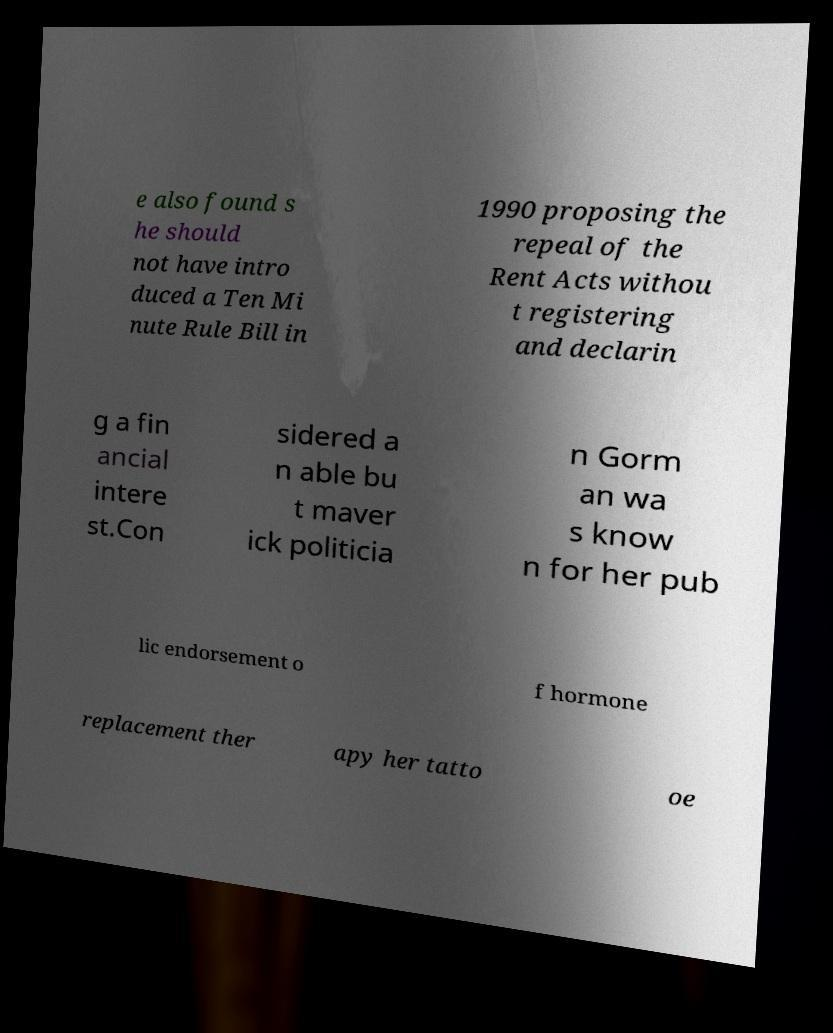I need the written content from this picture converted into text. Can you do that? e also found s he should not have intro duced a Ten Mi nute Rule Bill in 1990 proposing the repeal of the Rent Acts withou t registering and declarin g a fin ancial intere st.Con sidered a n able bu t maver ick politicia n Gorm an wa s know n for her pub lic endorsement o f hormone replacement ther apy her tatto oe 